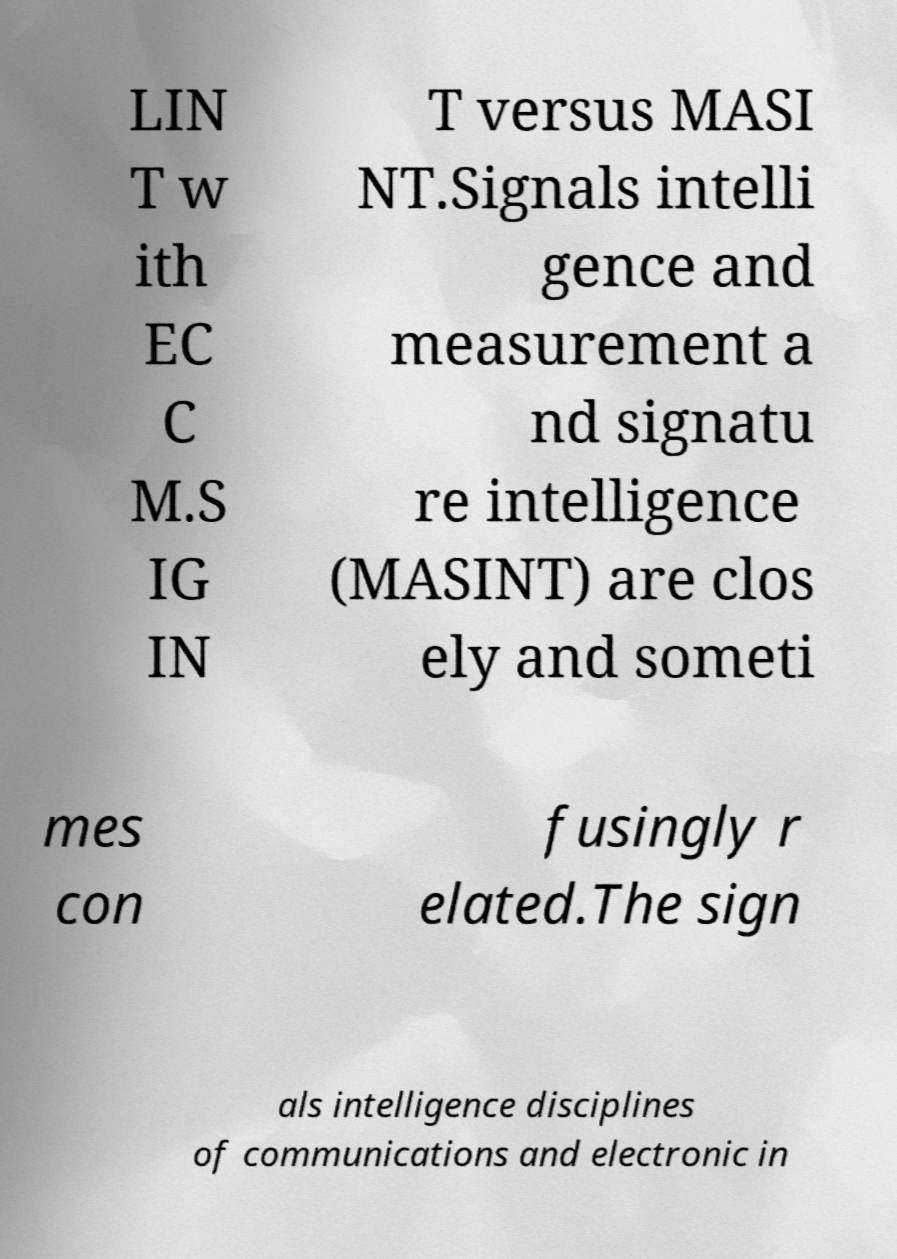Could you assist in decoding the text presented in this image and type it out clearly? LIN T w ith EC C M.S IG IN T versus MASI NT.Signals intelli gence and measurement a nd signatu re intelligence (MASINT) are clos ely and someti mes con fusingly r elated.The sign als intelligence disciplines of communications and electronic in 